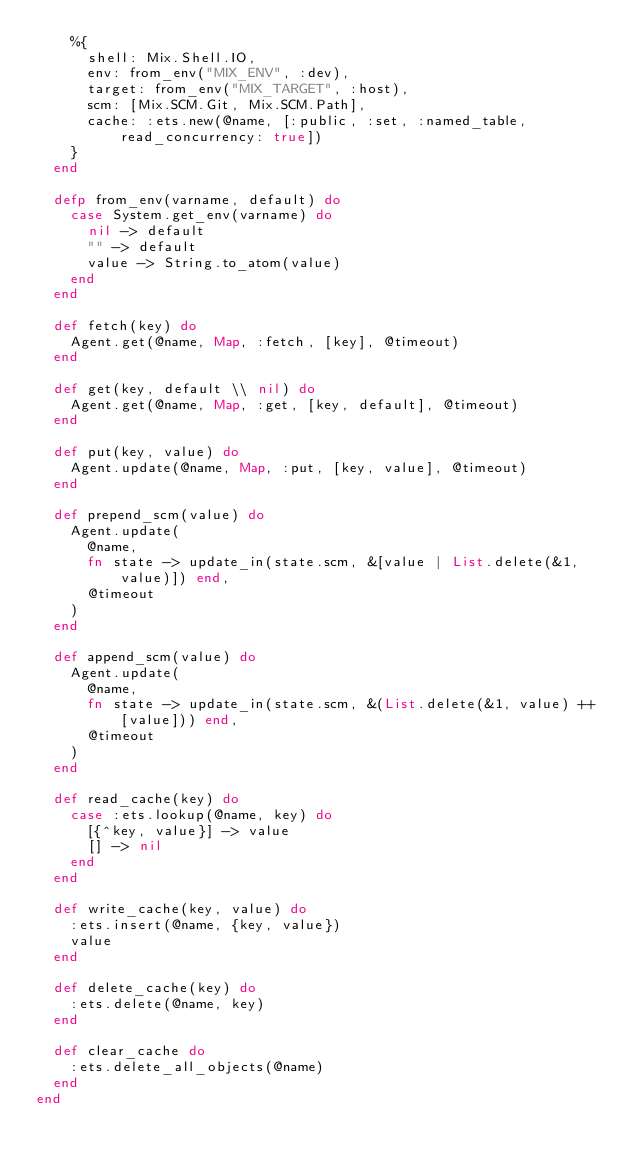<code> <loc_0><loc_0><loc_500><loc_500><_Elixir_>    %{
      shell: Mix.Shell.IO,
      env: from_env("MIX_ENV", :dev),
      target: from_env("MIX_TARGET", :host),
      scm: [Mix.SCM.Git, Mix.SCM.Path],
      cache: :ets.new(@name, [:public, :set, :named_table, read_concurrency: true])
    }
  end

  defp from_env(varname, default) do
    case System.get_env(varname) do
      nil -> default
      "" -> default
      value -> String.to_atom(value)
    end
  end

  def fetch(key) do
    Agent.get(@name, Map, :fetch, [key], @timeout)
  end

  def get(key, default \\ nil) do
    Agent.get(@name, Map, :get, [key, default], @timeout)
  end

  def put(key, value) do
    Agent.update(@name, Map, :put, [key, value], @timeout)
  end

  def prepend_scm(value) do
    Agent.update(
      @name,
      fn state -> update_in(state.scm, &[value | List.delete(&1, value)]) end,
      @timeout
    )
  end

  def append_scm(value) do
    Agent.update(
      @name,
      fn state -> update_in(state.scm, &(List.delete(&1, value) ++ [value])) end,
      @timeout
    )
  end

  def read_cache(key) do
    case :ets.lookup(@name, key) do
      [{^key, value}] -> value
      [] -> nil
    end
  end

  def write_cache(key, value) do
    :ets.insert(@name, {key, value})
    value
  end

  def delete_cache(key) do
    :ets.delete(@name, key)
  end

  def clear_cache do
    :ets.delete_all_objects(@name)
  end
end
</code> 